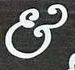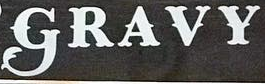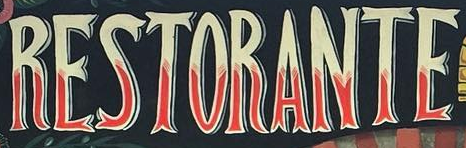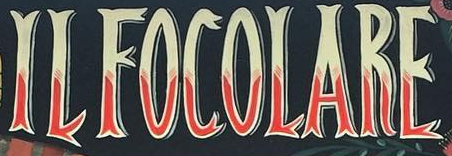What words can you see in these images in sequence, separated by a semicolon? &; GRAVY; RESTORANTE; ILFOCOLARE 